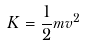<formula> <loc_0><loc_0><loc_500><loc_500>K = \frac { 1 } { 2 } m v ^ { 2 }</formula> 